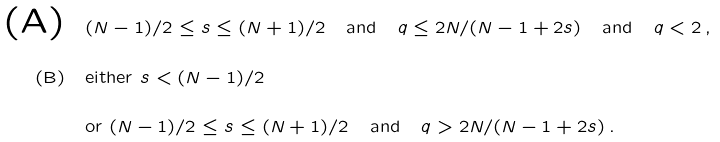Convert formula to latex. <formula><loc_0><loc_0><loc_500><loc_500>\text {(A)} & \quad ( N - 1 ) / 2 \leq s \leq ( N + 1 ) / 2 \quad \text {and} \quad q \leq 2 N / ( N - 1 + 2 s ) \quad \text {and} \quad q < 2 \, , \\ \text {(B)} & \quad \text {either} \ s < ( N - 1 ) / 2 \\ & \quad \text {or} \ ( N - 1 ) / 2 \leq s \leq ( N + 1 ) / 2 \quad \text {and} \quad q > 2 N / ( N - 1 + 2 s ) \, .</formula> 